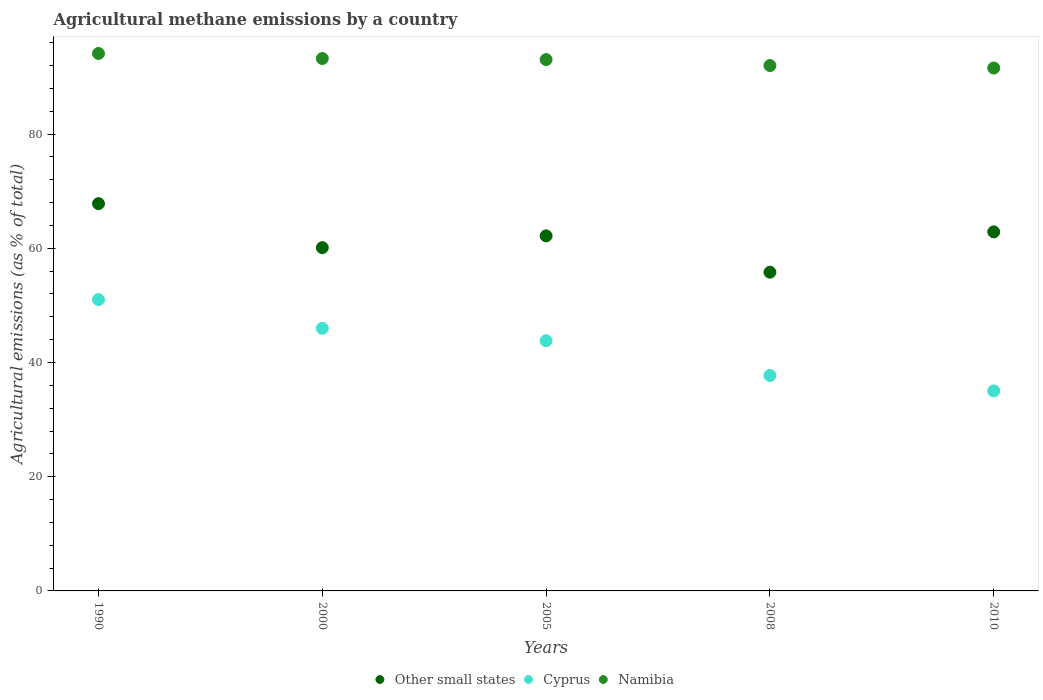What is the amount of agricultural methane emitted in Namibia in 2005?
Your answer should be very brief. 93.03. Across all years, what is the maximum amount of agricultural methane emitted in Other small states?
Ensure brevity in your answer.  67.81. Across all years, what is the minimum amount of agricultural methane emitted in Other small states?
Give a very brief answer. 55.81. In which year was the amount of agricultural methane emitted in Other small states maximum?
Make the answer very short. 1990. What is the total amount of agricultural methane emitted in Cyprus in the graph?
Make the answer very short. 213.54. What is the difference between the amount of agricultural methane emitted in Cyprus in 2008 and that in 2010?
Keep it short and to the point. 2.71. What is the difference between the amount of agricultural methane emitted in Cyprus in 2000 and the amount of agricultural methane emitted in Other small states in 2005?
Provide a short and direct response. -16.19. What is the average amount of agricultural methane emitted in Cyprus per year?
Ensure brevity in your answer.  42.71. In the year 2005, what is the difference between the amount of agricultural methane emitted in Cyprus and amount of agricultural methane emitted in Other small states?
Give a very brief answer. -18.36. What is the ratio of the amount of agricultural methane emitted in Namibia in 2000 to that in 2008?
Offer a very short reply. 1.01. Is the amount of agricultural methane emitted in Namibia in 1990 less than that in 2008?
Ensure brevity in your answer.  No. What is the difference between the highest and the second highest amount of agricultural methane emitted in Cyprus?
Offer a very short reply. 5.03. What is the difference between the highest and the lowest amount of agricultural methane emitted in Other small states?
Give a very brief answer. 12. In how many years, is the amount of agricultural methane emitted in Namibia greater than the average amount of agricultural methane emitted in Namibia taken over all years?
Provide a succinct answer. 3. Is the amount of agricultural methane emitted in Other small states strictly greater than the amount of agricultural methane emitted in Cyprus over the years?
Provide a short and direct response. Yes. What is the difference between two consecutive major ticks on the Y-axis?
Your answer should be compact. 20. Does the graph contain grids?
Offer a terse response. No. How many legend labels are there?
Make the answer very short. 3. What is the title of the graph?
Provide a succinct answer. Agricultural methane emissions by a country. What is the label or title of the X-axis?
Provide a succinct answer. Years. What is the label or title of the Y-axis?
Your answer should be compact. Agricultural emissions (as % of total). What is the Agricultural emissions (as % of total) in Other small states in 1990?
Make the answer very short. 67.81. What is the Agricultural emissions (as % of total) of Cyprus in 1990?
Provide a succinct answer. 51.01. What is the Agricultural emissions (as % of total) of Namibia in 1990?
Offer a terse response. 94.11. What is the Agricultural emissions (as % of total) of Other small states in 2000?
Offer a very short reply. 60.11. What is the Agricultural emissions (as % of total) of Cyprus in 2000?
Keep it short and to the point. 45.98. What is the Agricultural emissions (as % of total) in Namibia in 2000?
Your answer should be compact. 93.22. What is the Agricultural emissions (as % of total) in Other small states in 2005?
Offer a terse response. 62.17. What is the Agricultural emissions (as % of total) in Cyprus in 2005?
Provide a succinct answer. 43.81. What is the Agricultural emissions (as % of total) of Namibia in 2005?
Give a very brief answer. 93.03. What is the Agricultural emissions (as % of total) of Other small states in 2008?
Ensure brevity in your answer.  55.81. What is the Agricultural emissions (as % of total) in Cyprus in 2008?
Make the answer very short. 37.72. What is the Agricultural emissions (as % of total) in Namibia in 2008?
Ensure brevity in your answer.  91.99. What is the Agricultural emissions (as % of total) in Other small states in 2010?
Offer a very short reply. 62.87. What is the Agricultural emissions (as % of total) of Cyprus in 2010?
Provide a short and direct response. 35.02. What is the Agricultural emissions (as % of total) in Namibia in 2010?
Provide a succinct answer. 91.56. Across all years, what is the maximum Agricultural emissions (as % of total) of Other small states?
Provide a short and direct response. 67.81. Across all years, what is the maximum Agricultural emissions (as % of total) in Cyprus?
Your answer should be very brief. 51.01. Across all years, what is the maximum Agricultural emissions (as % of total) of Namibia?
Offer a terse response. 94.11. Across all years, what is the minimum Agricultural emissions (as % of total) in Other small states?
Provide a short and direct response. 55.81. Across all years, what is the minimum Agricultural emissions (as % of total) of Cyprus?
Your answer should be compact. 35.02. Across all years, what is the minimum Agricultural emissions (as % of total) in Namibia?
Make the answer very short. 91.56. What is the total Agricultural emissions (as % of total) in Other small states in the graph?
Offer a very short reply. 308.76. What is the total Agricultural emissions (as % of total) of Cyprus in the graph?
Provide a succinct answer. 213.54. What is the total Agricultural emissions (as % of total) in Namibia in the graph?
Offer a very short reply. 463.91. What is the difference between the Agricultural emissions (as % of total) in Other small states in 1990 and that in 2000?
Offer a terse response. 7.7. What is the difference between the Agricultural emissions (as % of total) of Cyprus in 1990 and that in 2000?
Your answer should be compact. 5.03. What is the difference between the Agricultural emissions (as % of total) in Namibia in 1990 and that in 2000?
Offer a very short reply. 0.88. What is the difference between the Agricultural emissions (as % of total) of Other small states in 1990 and that in 2005?
Your answer should be very brief. 5.64. What is the difference between the Agricultural emissions (as % of total) of Cyprus in 1990 and that in 2005?
Ensure brevity in your answer.  7.2. What is the difference between the Agricultural emissions (as % of total) of Namibia in 1990 and that in 2005?
Your answer should be very brief. 1.07. What is the difference between the Agricultural emissions (as % of total) of Other small states in 1990 and that in 2008?
Keep it short and to the point. 12. What is the difference between the Agricultural emissions (as % of total) of Cyprus in 1990 and that in 2008?
Your answer should be compact. 13.28. What is the difference between the Agricultural emissions (as % of total) of Namibia in 1990 and that in 2008?
Make the answer very short. 2.12. What is the difference between the Agricultural emissions (as % of total) of Other small states in 1990 and that in 2010?
Your answer should be very brief. 4.94. What is the difference between the Agricultural emissions (as % of total) of Cyprus in 1990 and that in 2010?
Keep it short and to the point. 15.99. What is the difference between the Agricultural emissions (as % of total) in Namibia in 1990 and that in 2010?
Your answer should be compact. 2.55. What is the difference between the Agricultural emissions (as % of total) of Other small states in 2000 and that in 2005?
Give a very brief answer. -2.06. What is the difference between the Agricultural emissions (as % of total) of Cyprus in 2000 and that in 2005?
Your answer should be compact. 2.17. What is the difference between the Agricultural emissions (as % of total) in Namibia in 2000 and that in 2005?
Offer a very short reply. 0.19. What is the difference between the Agricultural emissions (as % of total) in Other small states in 2000 and that in 2008?
Give a very brief answer. 4.3. What is the difference between the Agricultural emissions (as % of total) of Cyprus in 2000 and that in 2008?
Give a very brief answer. 8.25. What is the difference between the Agricultural emissions (as % of total) of Namibia in 2000 and that in 2008?
Your response must be concise. 1.24. What is the difference between the Agricultural emissions (as % of total) in Other small states in 2000 and that in 2010?
Your answer should be compact. -2.76. What is the difference between the Agricultural emissions (as % of total) in Cyprus in 2000 and that in 2010?
Provide a succinct answer. 10.96. What is the difference between the Agricultural emissions (as % of total) in Namibia in 2000 and that in 2010?
Provide a short and direct response. 1.67. What is the difference between the Agricultural emissions (as % of total) of Other small states in 2005 and that in 2008?
Your answer should be very brief. 6.36. What is the difference between the Agricultural emissions (as % of total) of Cyprus in 2005 and that in 2008?
Ensure brevity in your answer.  6.08. What is the difference between the Agricultural emissions (as % of total) in Namibia in 2005 and that in 2008?
Your answer should be compact. 1.05. What is the difference between the Agricultural emissions (as % of total) of Other small states in 2005 and that in 2010?
Make the answer very short. -0.7. What is the difference between the Agricultural emissions (as % of total) of Cyprus in 2005 and that in 2010?
Give a very brief answer. 8.79. What is the difference between the Agricultural emissions (as % of total) of Namibia in 2005 and that in 2010?
Ensure brevity in your answer.  1.48. What is the difference between the Agricultural emissions (as % of total) of Other small states in 2008 and that in 2010?
Offer a terse response. -7.06. What is the difference between the Agricultural emissions (as % of total) of Cyprus in 2008 and that in 2010?
Provide a succinct answer. 2.71. What is the difference between the Agricultural emissions (as % of total) of Namibia in 2008 and that in 2010?
Offer a terse response. 0.43. What is the difference between the Agricultural emissions (as % of total) in Other small states in 1990 and the Agricultural emissions (as % of total) in Cyprus in 2000?
Keep it short and to the point. 21.83. What is the difference between the Agricultural emissions (as % of total) of Other small states in 1990 and the Agricultural emissions (as % of total) of Namibia in 2000?
Offer a terse response. -25.42. What is the difference between the Agricultural emissions (as % of total) in Cyprus in 1990 and the Agricultural emissions (as % of total) in Namibia in 2000?
Offer a terse response. -42.21. What is the difference between the Agricultural emissions (as % of total) in Other small states in 1990 and the Agricultural emissions (as % of total) in Cyprus in 2005?
Give a very brief answer. 24. What is the difference between the Agricultural emissions (as % of total) in Other small states in 1990 and the Agricultural emissions (as % of total) in Namibia in 2005?
Offer a very short reply. -25.22. What is the difference between the Agricultural emissions (as % of total) of Cyprus in 1990 and the Agricultural emissions (as % of total) of Namibia in 2005?
Your answer should be very brief. -42.02. What is the difference between the Agricultural emissions (as % of total) in Other small states in 1990 and the Agricultural emissions (as % of total) in Cyprus in 2008?
Your answer should be very brief. 30.08. What is the difference between the Agricultural emissions (as % of total) of Other small states in 1990 and the Agricultural emissions (as % of total) of Namibia in 2008?
Provide a short and direct response. -24.18. What is the difference between the Agricultural emissions (as % of total) in Cyprus in 1990 and the Agricultural emissions (as % of total) in Namibia in 2008?
Provide a succinct answer. -40.98. What is the difference between the Agricultural emissions (as % of total) in Other small states in 1990 and the Agricultural emissions (as % of total) in Cyprus in 2010?
Offer a terse response. 32.79. What is the difference between the Agricultural emissions (as % of total) of Other small states in 1990 and the Agricultural emissions (as % of total) of Namibia in 2010?
Provide a short and direct response. -23.75. What is the difference between the Agricultural emissions (as % of total) of Cyprus in 1990 and the Agricultural emissions (as % of total) of Namibia in 2010?
Offer a terse response. -40.55. What is the difference between the Agricultural emissions (as % of total) of Other small states in 2000 and the Agricultural emissions (as % of total) of Cyprus in 2005?
Ensure brevity in your answer.  16.3. What is the difference between the Agricultural emissions (as % of total) in Other small states in 2000 and the Agricultural emissions (as % of total) in Namibia in 2005?
Your response must be concise. -32.93. What is the difference between the Agricultural emissions (as % of total) of Cyprus in 2000 and the Agricultural emissions (as % of total) of Namibia in 2005?
Give a very brief answer. -47.06. What is the difference between the Agricultural emissions (as % of total) of Other small states in 2000 and the Agricultural emissions (as % of total) of Cyprus in 2008?
Offer a very short reply. 22.38. What is the difference between the Agricultural emissions (as % of total) in Other small states in 2000 and the Agricultural emissions (as % of total) in Namibia in 2008?
Keep it short and to the point. -31.88. What is the difference between the Agricultural emissions (as % of total) of Cyprus in 2000 and the Agricultural emissions (as % of total) of Namibia in 2008?
Give a very brief answer. -46.01. What is the difference between the Agricultural emissions (as % of total) of Other small states in 2000 and the Agricultural emissions (as % of total) of Cyprus in 2010?
Offer a terse response. 25.09. What is the difference between the Agricultural emissions (as % of total) in Other small states in 2000 and the Agricultural emissions (as % of total) in Namibia in 2010?
Offer a terse response. -31.45. What is the difference between the Agricultural emissions (as % of total) of Cyprus in 2000 and the Agricultural emissions (as % of total) of Namibia in 2010?
Make the answer very short. -45.58. What is the difference between the Agricultural emissions (as % of total) in Other small states in 2005 and the Agricultural emissions (as % of total) in Cyprus in 2008?
Your response must be concise. 24.44. What is the difference between the Agricultural emissions (as % of total) in Other small states in 2005 and the Agricultural emissions (as % of total) in Namibia in 2008?
Your answer should be very brief. -29.82. What is the difference between the Agricultural emissions (as % of total) of Cyprus in 2005 and the Agricultural emissions (as % of total) of Namibia in 2008?
Make the answer very short. -48.18. What is the difference between the Agricultural emissions (as % of total) of Other small states in 2005 and the Agricultural emissions (as % of total) of Cyprus in 2010?
Give a very brief answer. 27.15. What is the difference between the Agricultural emissions (as % of total) in Other small states in 2005 and the Agricultural emissions (as % of total) in Namibia in 2010?
Provide a succinct answer. -29.39. What is the difference between the Agricultural emissions (as % of total) in Cyprus in 2005 and the Agricultural emissions (as % of total) in Namibia in 2010?
Offer a terse response. -47.75. What is the difference between the Agricultural emissions (as % of total) in Other small states in 2008 and the Agricultural emissions (as % of total) in Cyprus in 2010?
Make the answer very short. 20.79. What is the difference between the Agricultural emissions (as % of total) in Other small states in 2008 and the Agricultural emissions (as % of total) in Namibia in 2010?
Your response must be concise. -35.75. What is the difference between the Agricultural emissions (as % of total) of Cyprus in 2008 and the Agricultural emissions (as % of total) of Namibia in 2010?
Provide a succinct answer. -53.83. What is the average Agricultural emissions (as % of total) in Other small states per year?
Make the answer very short. 61.75. What is the average Agricultural emissions (as % of total) in Cyprus per year?
Keep it short and to the point. 42.71. What is the average Agricultural emissions (as % of total) in Namibia per year?
Your response must be concise. 92.78. In the year 1990, what is the difference between the Agricultural emissions (as % of total) in Other small states and Agricultural emissions (as % of total) in Cyprus?
Your answer should be compact. 16.8. In the year 1990, what is the difference between the Agricultural emissions (as % of total) in Other small states and Agricultural emissions (as % of total) in Namibia?
Provide a short and direct response. -26.3. In the year 1990, what is the difference between the Agricultural emissions (as % of total) in Cyprus and Agricultural emissions (as % of total) in Namibia?
Make the answer very short. -43.1. In the year 2000, what is the difference between the Agricultural emissions (as % of total) in Other small states and Agricultural emissions (as % of total) in Cyprus?
Your response must be concise. 14.13. In the year 2000, what is the difference between the Agricultural emissions (as % of total) of Other small states and Agricultural emissions (as % of total) of Namibia?
Provide a succinct answer. -33.12. In the year 2000, what is the difference between the Agricultural emissions (as % of total) in Cyprus and Agricultural emissions (as % of total) in Namibia?
Keep it short and to the point. -47.25. In the year 2005, what is the difference between the Agricultural emissions (as % of total) in Other small states and Agricultural emissions (as % of total) in Cyprus?
Your answer should be very brief. 18.36. In the year 2005, what is the difference between the Agricultural emissions (as % of total) of Other small states and Agricultural emissions (as % of total) of Namibia?
Offer a terse response. -30.86. In the year 2005, what is the difference between the Agricultural emissions (as % of total) in Cyprus and Agricultural emissions (as % of total) in Namibia?
Offer a terse response. -49.22. In the year 2008, what is the difference between the Agricultural emissions (as % of total) in Other small states and Agricultural emissions (as % of total) in Cyprus?
Offer a very short reply. 18.08. In the year 2008, what is the difference between the Agricultural emissions (as % of total) of Other small states and Agricultural emissions (as % of total) of Namibia?
Ensure brevity in your answer.  -36.18. In the year 2008, what is the difference between the Agricultural emissions (as % of total) in Cyprus and Agricultural emissions (as % of total) in Namibia?
Ensure brevity in your answer.  -54.26. In the year 2010, what is the difference between the Agricultural emissions (as % of total) of Other small states and Agricultural emissions (as % of total) of Cyprus?
Ensure brevity in your answer.  27.85. In the year 2010, what is the difference between the Agricultural emissions (as % of total) of Other small states and Agricultural emissions (as % of total) of Namibia?
Offer a terse response. -28.69. In the year 2010, what is the difference between the Agricultural emissions (as % of total) in Cyprus and Agricultural emissions (as % of total) in Namibia?
Your response must be concise. -56.54. What is the ratio of the Agricultural emissions (as % of total) in Other small states in 1990 to that in 2000?
Provide a short and direct response. 1.13. What is the ratio of the Agricultural emissions (as % of total) of Cyprus in 1990 to that in 2000?
Ensure brevity in your answer.  1.11. What is the ratio of the Agricultural emissions (as % of total) in Namibia in 1990 to that in 2000?
Provide a succinct answer. 1.01. What is the ratio of the Agricultural emissions (as % of total) in Other small states in 1990 to that in 2005?
Your answer should be very brief. 1.09. What is the ratio of the Agricultural emissions (as % of total) in Cyprus in 1990 to that in 2005?
Offer a terse response. 1.16. What is the ratio of the Agricultural emissions (as % of total) in Namibia in 1990 to that in 2005?
Offer a terse response. 1.01. What is the ratio of the Agricultural emissions (as % of total) of Other small states in 1990 to that in 2008?
Keep it short and to the point. 1.22. What is the ratio of the Agricultural emissions (as % of total) of Cyprus in 1990 to that in 2008?
Your response must be concise. 1.35. What is the ratio of the Agricultural emissions (as % of total) of Namibia in 1990 to that in 2008?
Your answer should be very brief. 1.02. What is the ratio of the Agricultural emissions (as % of total) in Other small states in 1990 to that in 2010?
Offer a terse response. 1.08. What is the ratio of the Agricultural emissions (as % of total) of Cyprus in 1990 to that in 2010?
Give a very brief answer. 1.46. What is the ratio of the Agricultural emissions (as % of total) in Namibia in 1990 to that in 2010?
Your answer should be very brief. 1.03. What is the ratio of the Agricultural emissions (as % of total) in Other small states in 2000 to that in 2005?
Your answer should be very brief. 0.97. What is the ratio of the Agricultural emissions (as % of total) of Cyprus in 2000 to that in 2005?
Your answer should be compact. 1.05. What is the ratio of the Agricultural emissions (as % of total) in Namibia in 2000 to that in 2005?
Keep it short and to the point. 1. What is the ratio of the Agricultural emissions (as % of total) of Other small states in 2000 to that in 2008?
Offer a very short reply. 1.08. What is the ratio of the Agricultural emissions (as % of total) of Cyprus in 2000 to that in 2008?
Give a very brief answer. 1.22. What is the ratio of the Agricultural emissions (as % of total) in Namibia in 2000 to that in 2008?
Offer a very short reply. 1.01. What is the ratio of the Agricultural emissions (as % of total) in Other small states in 2000 to that in 2010?
Provide a succinct answer. 0.96. What is the ratio of the Agricultural emissions (as % of total) in Cyprus in 2000 to that in 2010?
Provide a succinct answer. 1.31. What is the ratio of the Agricultural emissions (as % of total) of Namibia in 2000 to that in 2010?
Keep it short and to the point. 1.02. What is the ratio of the Agricultural emissions (as % of total) of Other small states in 2005 to that in 2008?
Offer a terse response. 1.11. What is the ratio of the Agricultural emissions (as % of total) in Cyprus in 2005 to that in 2008?
Ensure brevity in your answer.  1.16. What is the ratio of the Agricultural emissions (as % of total) in Namibia in 2005 to that in 2008?
Provide a succinct answer. 1.01. What is the ratio of the Agricultural emissions (as % of total) in Cyprus in 2005 to that in 2010?
Make the answer very short. 1.25. What is the ratio of the Agricultural emissions (as % of total) in Namibia in 2005 to that in 2010?
Offer a terse response. 1.02. What is the ratio of the Agricultural emissions (as % of total) of Other small states in 2008 to that in 2010?
Offer a very short reply. 0.89. What is the ratio of the Agricultural emissions (as % of total) in Cyprus in 2008 to that in 2010?
Your answer should be very brief. 1.08. What is the difference between the highest and the second highest Agricultural emissions (as % of total) in Other small states?
Provide a succinct answer. 4.94. What is the difference between the highest and the second highest Agricultural emissions (as % of total) in Cyprus?
Give a very brief answer. 5.03. What is the difference between the highest and the second highest Agricultural emissions (as % of total) of Namibia?
Offer a very short reply. 0.88. What is the difference between the highest and the lowest Agricultural emissions (as % of total) in Other small states?
Your answer should be very brief. 12. What is the difference between the highest and the lowest Agricultural emissions (as % of total) in Cyprus?
Keep it short and to the point. 15.99. What is the difference between the highest and the lowest Agricultural emissions (as % of total) of Namibia?
Your response must be concise. 2.55. 